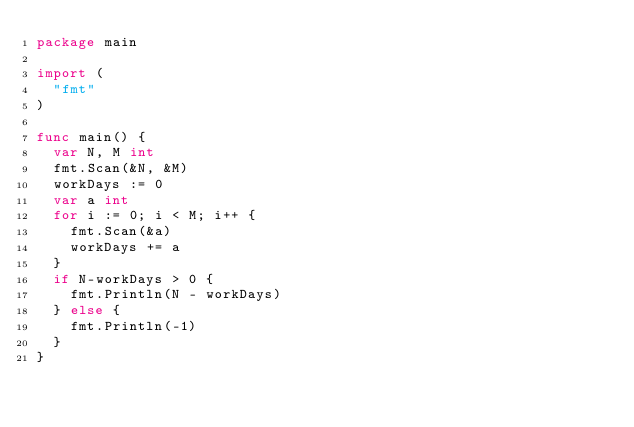Convert code to text. <code><loc_0><loc_0><loc_500><loc_500><_Go_>package main

import (
	"fmt"
)

func main() {
	var N, M int
	fmt.Scan(&N, &M)
	workDays := 0
	var a int
	for i := 0; i < M; i++ {
		fmt.Scan(&a)
		workDays += a
	}
	if N-workDays > 0 {
		fmt.Println(N - workDays)
	} else {
		fmt.Println(-1)
	}
}
</code> 